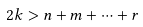<formula> <loc_0><loc_0><loc_500><loc_500>2 k > n + m + \dots + r</formula> 